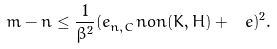<formula> <loc_0><loc_0><loc_500><loc_500>m - n \leq \frac { 1 } { \beta ^ { 2 } } ( e _ { n , C } ^ { \ } n o n ( K , H ) + \ e ) ^ { 2 } .</formula> 